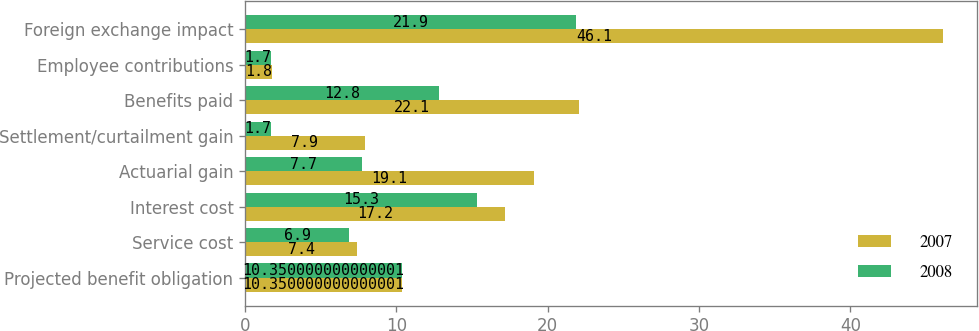<chart> <loc_0><loc_0><loc_500><loc_500><stacked_bar_chart><ecel><fcel>Projected benefit obligation<fcel>Service cost<fcel>Interest cost<fcel>Actuarial gain<fcel>Settlement/curtailment gain<fcel>Benefits paid<fcel>Employee contributions<fcel>Foreign exchange impact<nl><fcel>2007<fcel>10.35<fcel>7.4<fcel>17.2<fcel>19.1<fcel>7.9<fcel>22.1<fcel>1.8<fcel>46.1<nl><fcel>2008<fcel>10.35<fcel>6.9<fcel>15.3<fcel>7.7<fcel>1.7<fcel>12.8<fcel>1.7<fcel>21.9<nl></chart> 